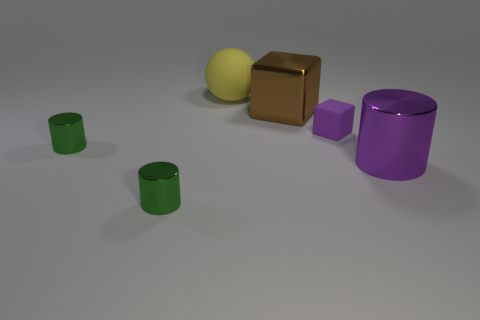Is there any other thing that is the same shape as the large matte object?
Ensure brevity in your answer.  No. What number of spheres are either yellow rubber things or large cyan rubber objects?
Make the answer very short. 1. How big is the cylinder that is right of the yellow object that is behind the green thing in front of the big purple cylinder?
Give a very brief answer. Large. Are there any big objects behind the brown shiny block?
Your response must be concise. Yes. The thing that is the same color as the big metal cylinder is what shape?
Give a very brief answer. Cube. What number of objects are tiny objects in front of the large purple cylinder or tiny brown shiny things?
Offer a very short reply. 1. What is the size of the sphere that is the same material as the small purple object?
Offer a terse response. Large. There is a purple cylinder; is its size the same as the green shiny object behind the large purple metallic thing?
Provide a succinct answer. No. There is a object that is both on the right side of the big yellow ball and on the left side of the tiny purple cube; what is its color?
Offer a terse response. Brown. How many objects are small green objects behind the large metallic cylinder or shiny objects behind the matte block?
Give a very brief answer. 2. 